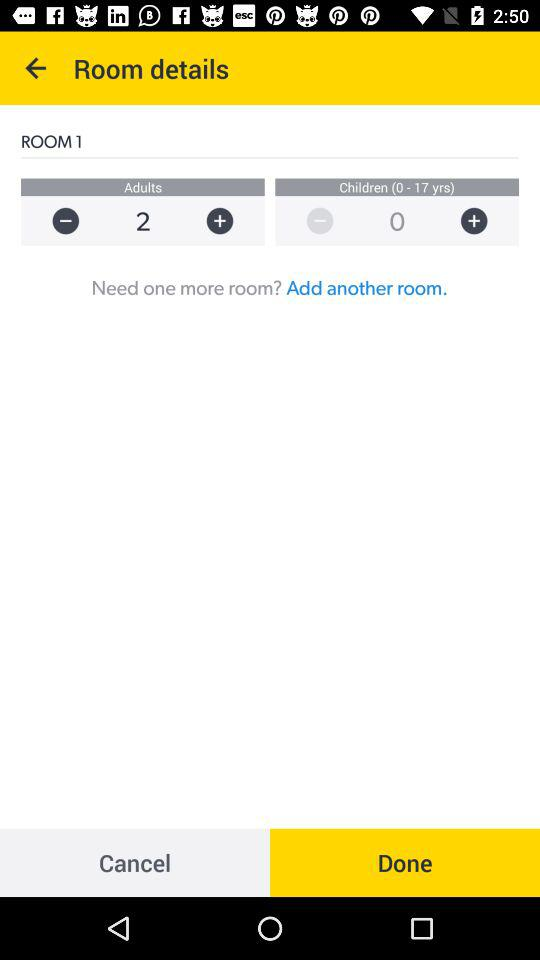What is the total number of adults selected for "ROOM 1"? The total number of adults selected for "ROOM 1" is 2. 